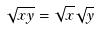<formula> <loc_0><loc_0><loc_500><loc_500>\sqrt { x y } = \sqrt { x } \sqrt { y }</formula> 